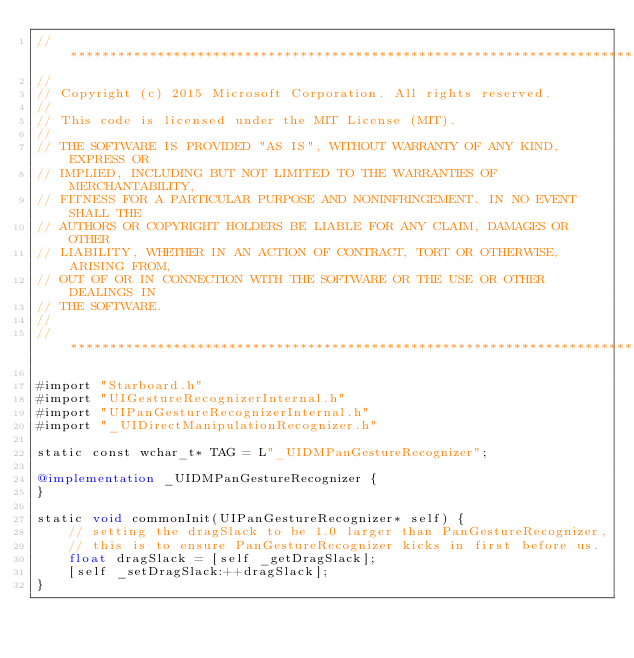<code> <loc_0><loc_0><loc_500><loc_500><_ObjectiveC_>//******************************************************************************
//
// Copyright (c) 2015 Microsoft Corporation. All rights reserved.
//
// This code is licensed under the MIT License (MIT).
//
// THE SOFTWARE IS PROVIDED "AS IS", WITHOUT WARRANTY OF ANY KIND, EXPRESS OR
// IMPLIED, INCLUDING BUT NOT LIMITED TO THE WARRANTIES OF MERCHANTABILITY,
// FITNESS FOR A PARTICULAR PURPOSE AND NONINFRINGEMENT. IN NO EVENT SHALL THE
// AUTHORS OR COPYRIGHT HOLDERS BE LIABLE FOR ANY CLAIM, DAMAGES OR OTHER
// LIABILITY, WHETHER IN AN ACTION OF CONTRACT, TORT OR OTHERWISE, ARISING FROM,
// OUT OF OR IN CONNECTION WITH THE SOFTWARE OR THE USE OR OTHER DEALINGS IN
// THE SOFTWARE.
//
//******************************************************************************

#import "Starboard.h"
#import "UIGestureRecognizerInternal.h"
#import "UIPanGestureRecognizerInternal.h"
#import "_UIDirectManipulationRecognizer.h"

static const wchar_t* TAG = L"_UIDMPanGestureRecognizer";

@implementation _UIDMPanGestureRecognizer {
}

static void commonInit(UIPanGestureRecognizer* self) {
    // setting the dragSlack to be 1.0 larger than PanGestureRecognizer,
    // this is to ensure PanGestureRecognizer kicks in first before us.
    float dragSlack = [self _getDragSlack];
    [self _setDragSlack:++dragSlack];
}
</code> 